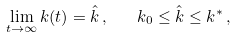Convert formula to latex. <formula><loc_0><loc_0><loc_500><loc_500>\lim _ { t \rightarrow \infty } k ( t ) = \hat { k } \, , \quad k _ { 0 } \leq \hat { k } \leq k ^ { * } \, ,</formula> 